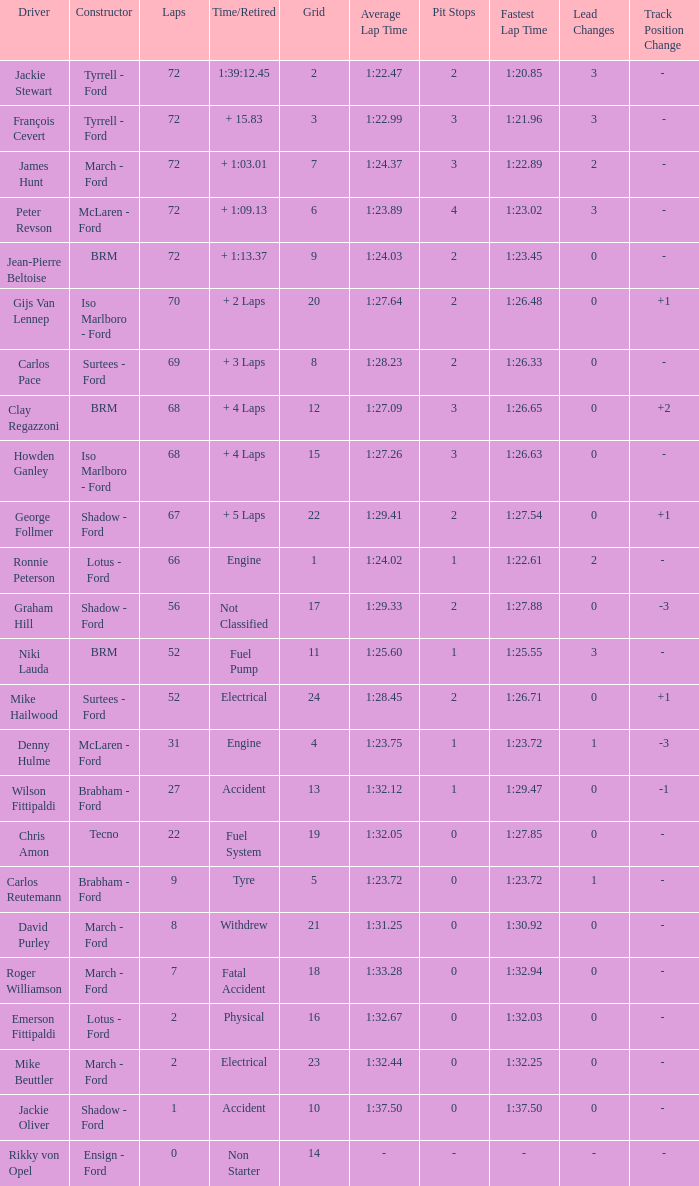What is the top lap that had a tyre time? 9.0. 